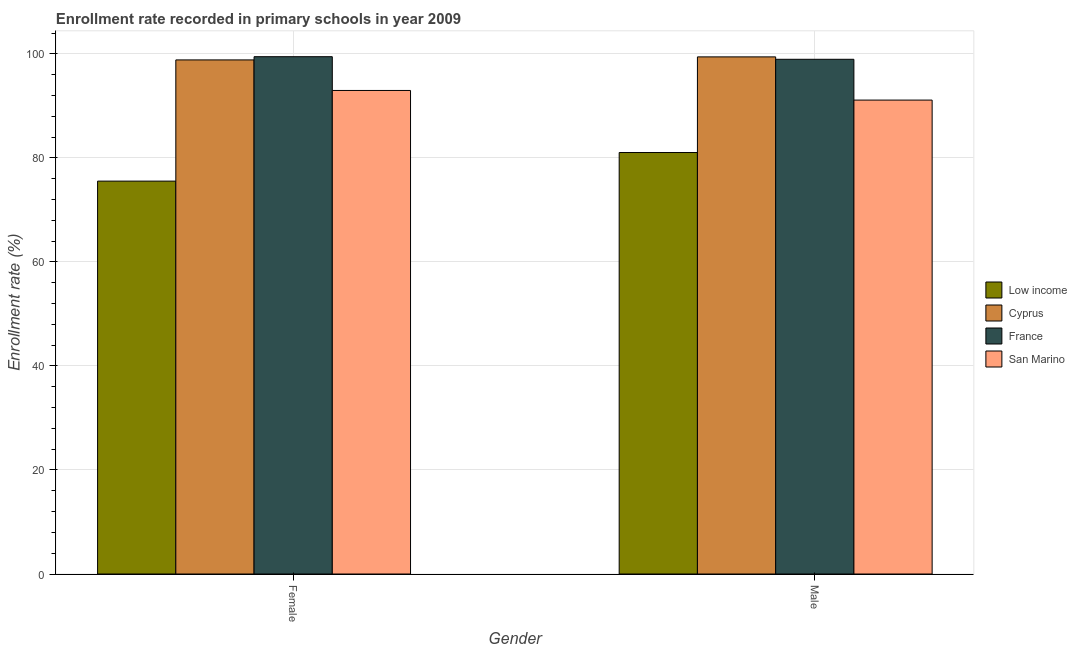How many groups of bars are there?
Your response must be concise. 2. Are the number of bars on each tick of the X-axis equal?
Offer a very short reply. Yes. What is the label of the 2nd group of bars from the left?
Offer a very short reply. Male. What is the enrollment rate of male students in France?
Your response must be concise. 98.97. Across all countries, what is the maximum enrollment rate of female students?
Your answer should be very brief. 99.47. Across all countries, what is the minimum enrollment rate of male students?
Make the answer very short. 81.04. In which country was the enrollment rate of male students maximum?
Your answer should be compact. Cyprus. What is the total enrollment rate of female students in the graph?
Keep it short and to the point. 366.83. What is the difference between the enrollment rate of male students in Cyprus and that in France?
Offer a very short reply. 0.46. What is the difference between the enrollment rate of male students in San Marino and the enrollment rate of female students in Low income?
Give a very brief answer. 15.58. What is the average enrollment rate of male students per country?
Offer a terse response. 92.64. What is the difference between the enrollment rate of female students and enrollment rate of male students in San Marino?
Offer a terse response. 1.85. What is the ratio of the enrollment rate of female students in France to that in Low income?
Provide a succinct answer. 1.32. What does the 2nd bar from the left in Male represents?
Offer a very short reply. Cyprus. What does the 3rd bar from the right in Female represents?
Provide a succinct answer. Cyprus. How many bars are there?
Give a very brief answer. 8. How many countries are there in the graph?
Offer a terse response. 4. Are the values on the major ticks of Y-axis written in scientific E-notation?
Your answer should be very brief. No. How are the legend labels stacked?
Provide a short and direct response. Vertical. What is the title of the graph?
Your response must be concise. Enrollment rate recorded in primary schools in year 2009. What is the label or title of the X-axis?
Your answer should be compact. Gender. What is the label or title of the Y-axis?
Your response must be concise. Enrollment rate (%). What is the Enrollment rate (%) of Low income in Female?
Provide a succinct answer. 75.54. What is the Enrollment rate (%) of Cyprus in Female?
Offer a very short reply. 98.85. What is the Enrollment rate (%) in France in Female?
Your answer should be compact. 99.47. What is the Enrollment rate (%) of San Marino in Female?
Provide a short and direct response. 92.97. What is the Enrollment rate (%) of Low income in Male?
Ensure brevity in your answer.  81.04. What is the Enrollment rate (%) of Cyprus in Male?
Keep it short and to the point. 99.43. What is the Enrollment rate (%) in France in Male?
Provide a succinct answer. 98.97. What is the Enrollment rate (%) in San Marino in Male?
Make the answer very short. 91.12. Across all Gender, what is the maximum Enrollment rate (%) in Low income?
Ensure brevity in your answer.  81.04. Across all Gender, what is the maximum Enrollment rate (%) in Cyprus?
Offer a terse response. 99.43. Across all Gender, what is the maximum Enrollment rate (%) in France?
Provide a succinct answer. 99.47. Across all Gender, what is the maximum Enrollment rate (%) in San Marino?
Provide a succinct answer. 92.97. Across all Gender, what is the minimum Enrollment rate (%) in Low income?
Ensure brevity in your answer.  75.54. Across all Gender, what is the minimum Enrollment rate (%) in Cyprus?
Offer a very short reply. 98.85. Across all Gender, what is the minimum Enrollment rate (%) in France?
Make the answer very short. 98.97. Across all Gender, what is the minimum Enrollment rate (%) of San Marino?
Ensure brevity in your answer.  91.12. What is the total Enrollment rate (%) in Low income in the graph?
Your response must be concise. 156.58. What is the total Enrollment rate (%) in Cyprus in the graph?
Provide a short and direct response. 198.28. What is the total Enrollment rate (%) in France in the graph?
Your answer should be very brief. 198.43. What is the total Enrollment rate (%) of San Marino in the graph?
Offer a terse response. 184.1. What is the difference between the Enrollment rate (%) in Low income in Female and that in Male?
Offer a terse response. -5.5. What is the difference between the Enrollment rate (%) of Cyprus in Female and that in Male?
Keep it short and to the point. -0.58. What is the difference between the Enrollment rate (%) of France in Female and that in Male?
Make the answer very short. 0.5. What is the difference between the Enrollment rate (%) of San Marino in Female and that in Male?
Ensure brevity in your answer.  1.85. What is the difference between the Enrollment rate (%) of Low income in Female and the Enrollment rate (%) of Cyprus in Male?
Your response must be concise. -23.89. What is the difference between the Enrollment rate (%) of Low income in Female and the Enrollment rate (%) of France in Male?
Offer a very short reply. -23.42. What is the difference between the Enrollment rate (%) in Low income in Female and the Enrollment rate (%) in San Marino in Male?
Your answer should be very brief. -15.58. What is the difference between the Enrollment rate (%) of Cyprus in Female and the Enrollment rate (%) of France in Male?
Give a very brief answer. -0.12. What is the difference between the Enrollment rate (%) in Cyprus in Female and the Enrollment rate (%) in San Marino in Male?
Provide a short and direct response. 7.72. What is the difference between the Enrollment rate (%) of France in Female and the Enrollment rate (%) of San Marino in Male?
Offer a very short reply. 8.34. What is the average Enrollment rate (%) of Low income per Gender?
Offer a terse response. 78.29. What is the average Enrollment rate (%) of Cyprus per Gender?
Offer a very short reply. 99.14. What is the average Enrollment rate (%) in France per Gender?
Give a very brief answer. 99.22. What is the average Enrollment rate (%) of San Marino per Gender?
Provide a short and direct response. 92.05. What is the difference between the Enrollment rate (%) in Low income and Enrollment rate (%) in Cyprus in Female?
Provide a short and direct response. -23.3. What is the difference between the Enrollment rate (%) of Low income and Enrollment rate (%) of France in Female?
Provide a succinct answer. -23.92. What is the difference between the Enrollment rate (%) in Low income and Enrollment rate (%) in San Marino in Female?
Make the answer very short. -17.43. What is the difference between the Enrollment rate (%) in Cyprus and Enrollment rate (%) in France in Female?
Offer a terse response. -0.62. What is the difference between the Enrollment rate (%) in Cyprus and Enrollment rate (%) in San Marino in Female?
Your answer should be very brief. 5.87. What is the difference between the Enrollment rate (%) in France and Enrollment rate (%) in San Marino in Female?
Your answer should be very brief. 6.49. What is the difference between the Enrollment rate (%) of Low income and Enrollment rate (%) of Cyprus in Male?
Provide a succinct answer. -18.39. What is the difference between the Enrollment rate (%) of Low income and Enrollment rate (%) of France in Male?
Your response must be concise. -17.93. What is the difference between the Enrollment rate (%) of Low income and Enrollment rate (%) of San Marino in Male?
Make the answer very short. -10.08. What is the difference between the Enrollment rate (%) in Cyprus and Enrollment rate (%) in France in Male?
Your answer should be compact. 0.46. What is the difference between the Enrollment rate (%) of Cyprus and Enrollment rate (%) of San Marino in Male?
Provide a succinct answer. 8.31. What is the difference between the Enrollment rate (%) in France and Enrollment rate (%) in San Marino in Male?
Make the answer very short. 7.84. What is the ratio of the Enrollment rate (%) of Low income in Female to that in Male?
Offer a very short reply. 0.93. What is the ratio of the Enrollment rate (%) of Cyprus in Female to that in Male?
Your answer should be very brief. 0.99. What is the ratio of the Enrollment rate (%) in France in Female to that in Male?
Provide a short and direct response. 1. What is the ratio of the Enrollment rate (%) in San Marino in Female to that in Male?
Make the answer very short. 1.02. What is the difference between the highest and the second highest Enrollment rate (%) of Low income?
Offer a terse response. 5.5. What is the difference between the highest and the second highest Enrollment rate (%) of Cyprus?
Keep it short and to the point. 0.58. What is the difference between the highest and the second highest Enrollment rate (%) in France?
Provide a succinct answer. 0.5. What is the difference between the highest and the second highest Enrollment rate (%) of San Marino?
Your answer should be compact. 1.85. What is the difference between the highest and the lowest Enrollment rate (%) of Low income?
Make the answer very short. 5.5. What is the difference between the highest and the lowest Enrollment rate (%) of Cyprus?
Your response must be concise. 0.58. What is the difference between the highest and the lowest Enrollment rate (%) in France?
Your response must be concise. 0.5. What is the difference between the highest and the lowest Enrollment rate (%) of San Marino?
Give a very brief answer. 1.85. 